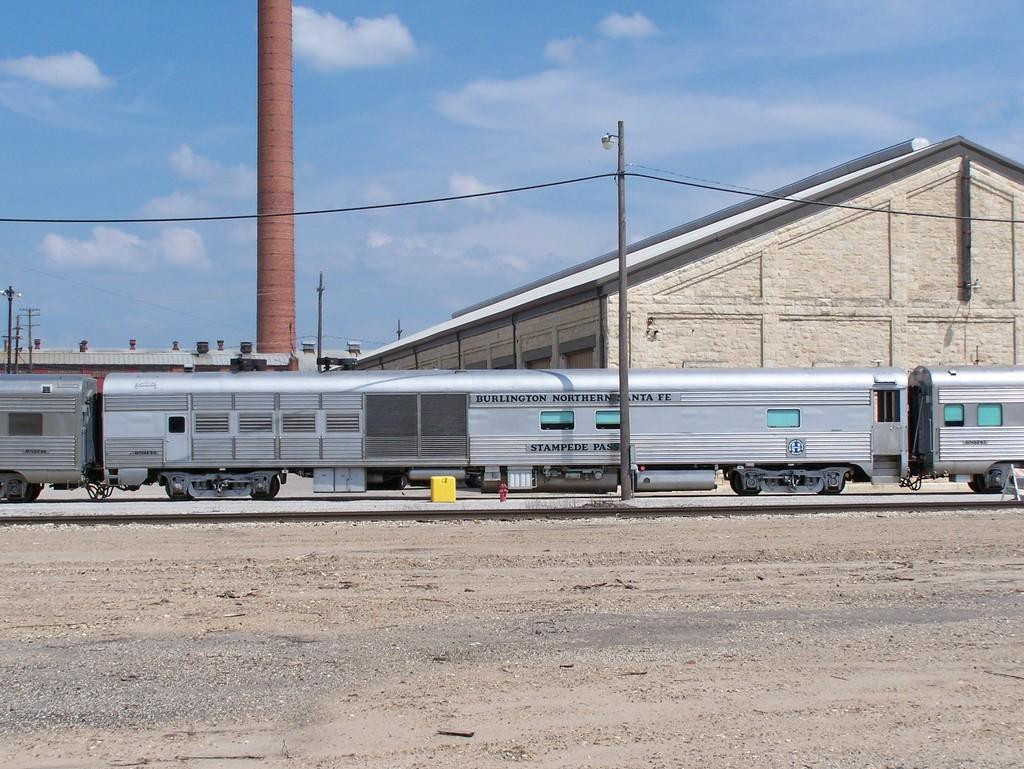<image>
Write a terse but informative summary of the picture. Stampede Pass is painted onto the side of a silver train. 